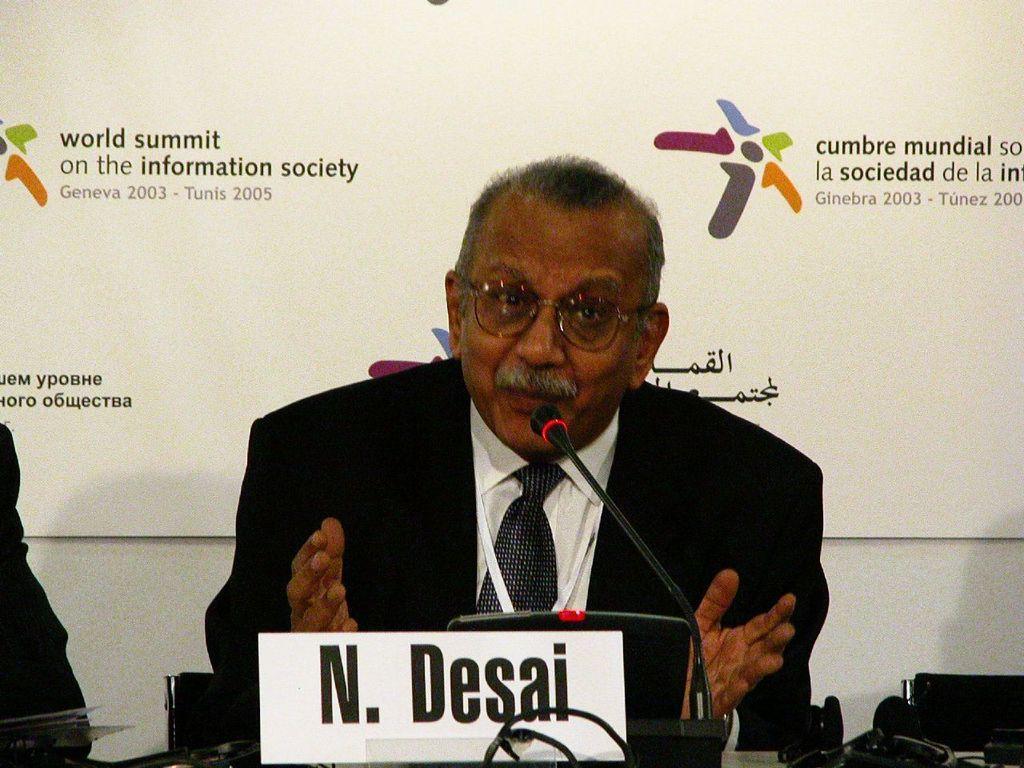Could you give a brief overview of what you see in this image? In the image there is an old man with black suit and white shirt sitting in front of table talking on mic, behind him there is a banner. 